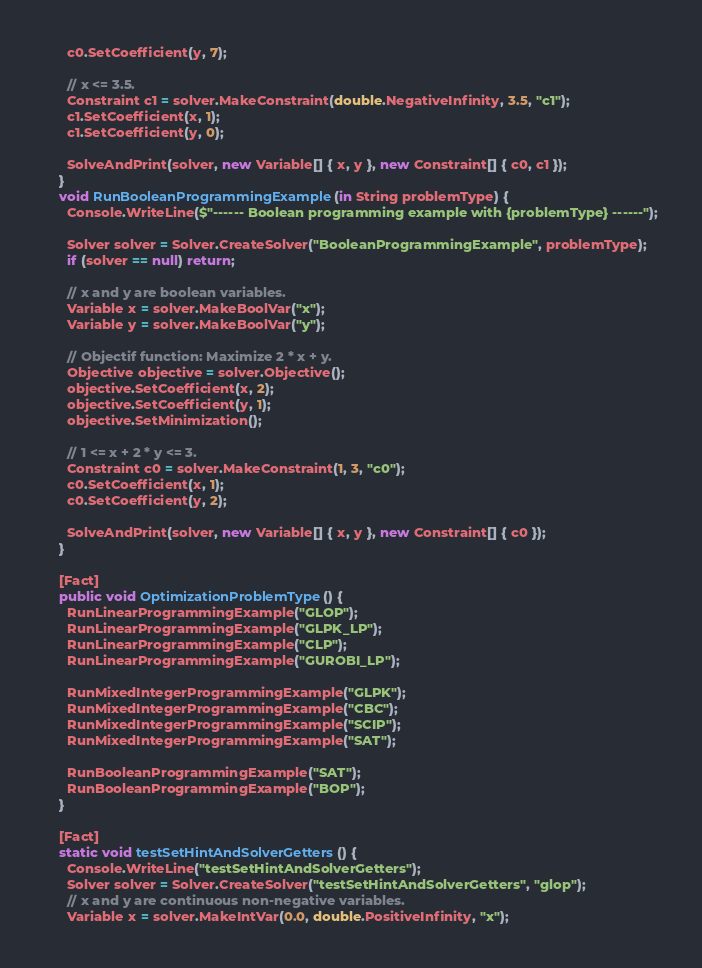Convert code to text. <code><loc_0><loc_0><loc_500><loc_500><_C#_>      c0.SetCoefficient(y, 7);

      // x <= 3.5.
      Constraint c1 = solver.MakeConstraint(double.NegativeInfinity, 3.5, "c1");
      c1.SetCoefficient(x, 1);
      c1.SetCoefficient(y, 0);

      SolveAndPrint(solver, new Variable[] { x, y }, new Constraint[] { c0, c1 });
    }
    void RunBooleanProgrammingExample(in String problemType) {
      Console.WriteLine($"------ Boolean programming example with {problemType} ------");

      Solver solver = Solver.CreateSolver("BooleanProgrammingExample", problemType);
      if (solver == null) return;

      // x and y are boolean variables.
      Variable x = solver.MakeBoolVar("x");
      Variable y = solver.MakeBoolVar("y");

      // Objectif function: Maximize 2 * x + y.
      Objective objective = solver.Objective();
      objective.SetCoefficient(x, 2);
      objective.SetCoefficient(y, 1);
      objective.SetMinimization();

      // 1 <= x + 2 * y <= 3.
      Constraint c0 = solver.MakeConstraint(1, 3, "c0");
      c0.SetCoefficient(x, 1);
      c0.SetCoefficient(y, 2);

      SolveAndPrint(solver, new Variable[] { x, y }, new Constraint[] { c0 });
    }

    [Fact]
    public void OptimizationProblemType() {
      RunLinearProgrammingExample("GLOP");
      RunLinearProgrammingExample("GLPK_LP");
      RunLinearProgrammingExample("CLP");
      RunLinearProgrammingExample("GUROBI_LP");

      RunMixedIntegerProgrammingExample("GLPK");
      RunMixedIntegerProgrammingExample("CBC");
      RunMixedIntegerProgrammingExample("SCIP");
      RunMixedIntegerProgrammingExample("SAT");

      RunBooleanProgrammingExample("SAT");
      RunBooleanProgrammingExample("BOP");
    }

    [Fact]
    static void testSetHintAndSolverGetters() {
      Console.WriteLine("testSetHintAndSolverGetters");
      Solver solver = Solver.CreateSolver("testSetHintAndSolverGetters", "glop");
      // x and y are continuous non-negative variables.
      Variable x = solver.MakeIntVar(0.0, double.PositiveInfinity, "x");</code> 